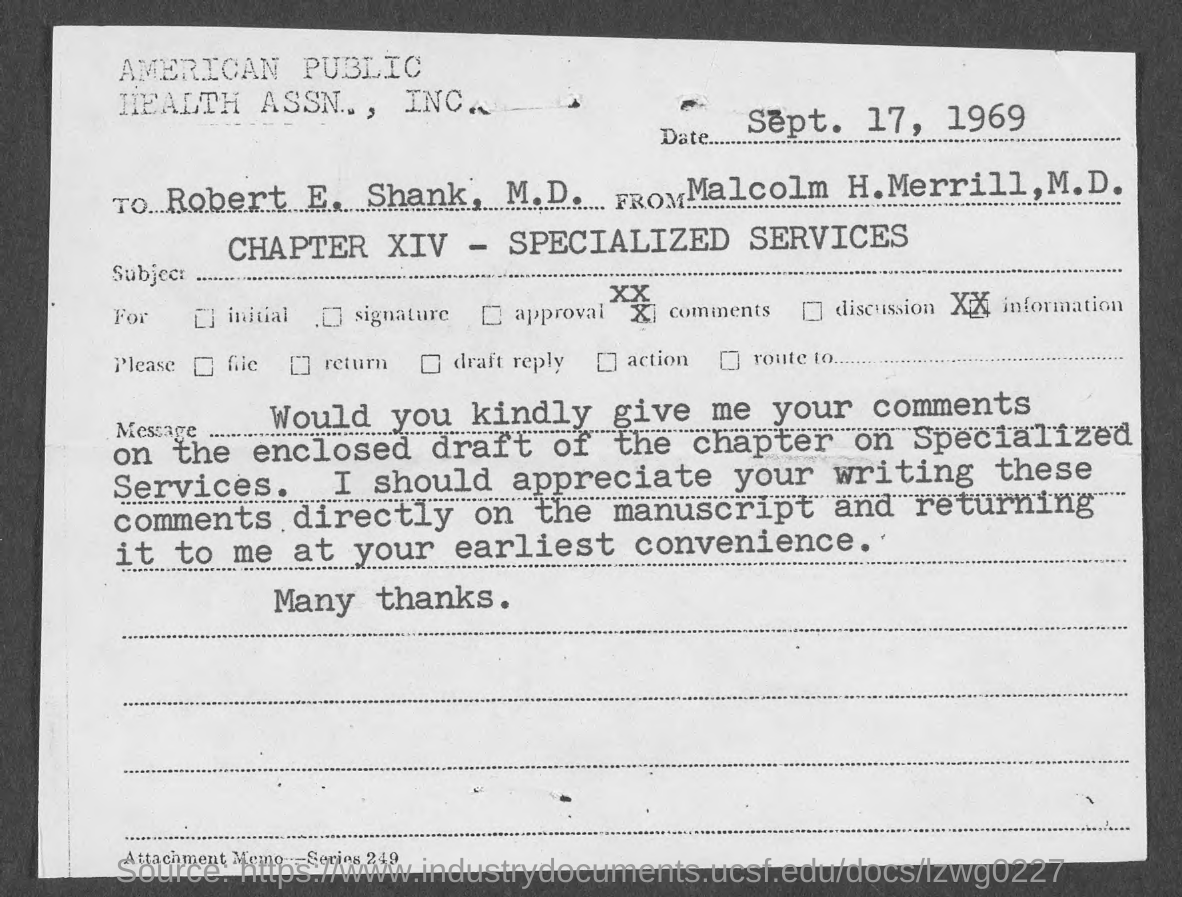What is the attachment memo series no.?
Your response must be concise. 249. When is the memorandum dated?
Make the answer very short. Sept. 17, 1969. What does chapter xiv deals with ?
Give a very brief answer. Specialized services. To whom is this memo for?
Your response must be concise. Robert E. Shank, M.D. 